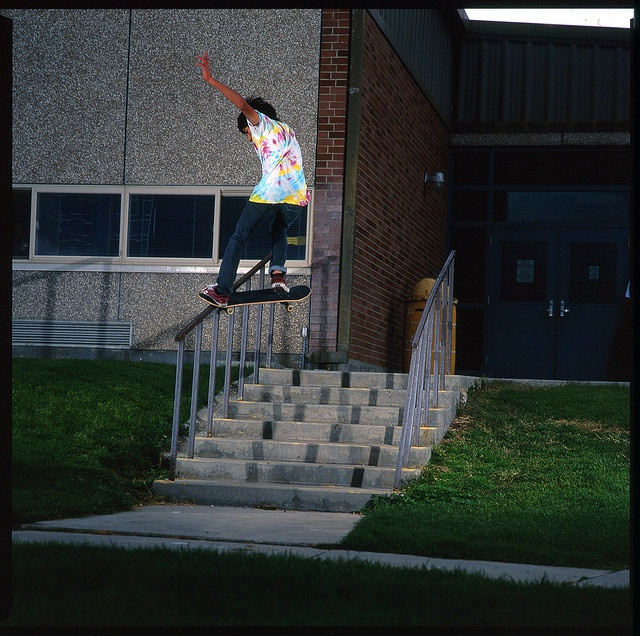Describe the objects in this image and their specific colors. I can see people in black, lavender, lightblue, and gray tones and skateboard in black, gray, maroon, and darkgray tones in this image. 